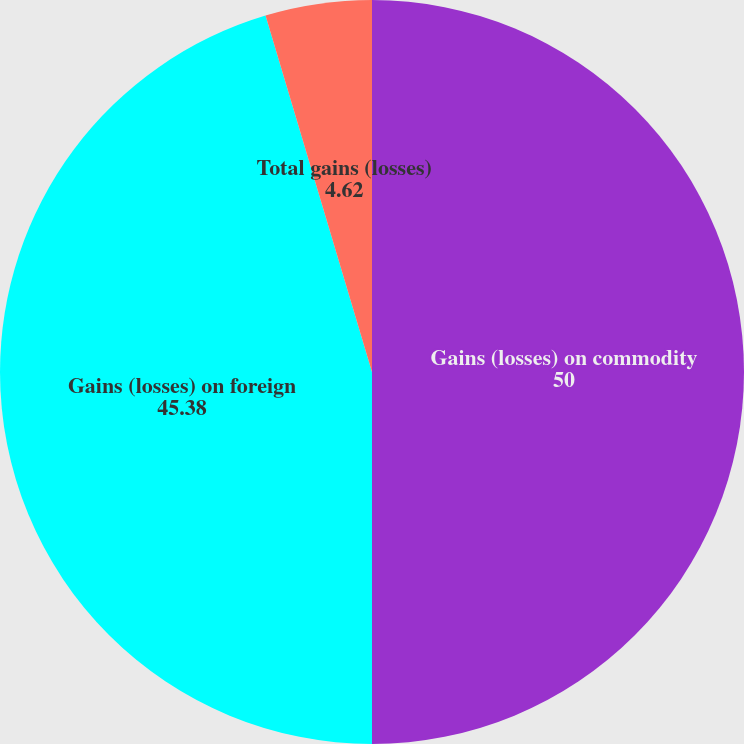Convert chart to OTSL. <chart><loc_0><loc_0><loc_500><loc_500><pie_chart><fcel>Gains (losses) on commodity<fcel>Gains (losses) on foreign<fcel>Total gains (losses)<nl><fcel>50.0%<fcel>45.38%<fcel>4.62%<nl></chart> 